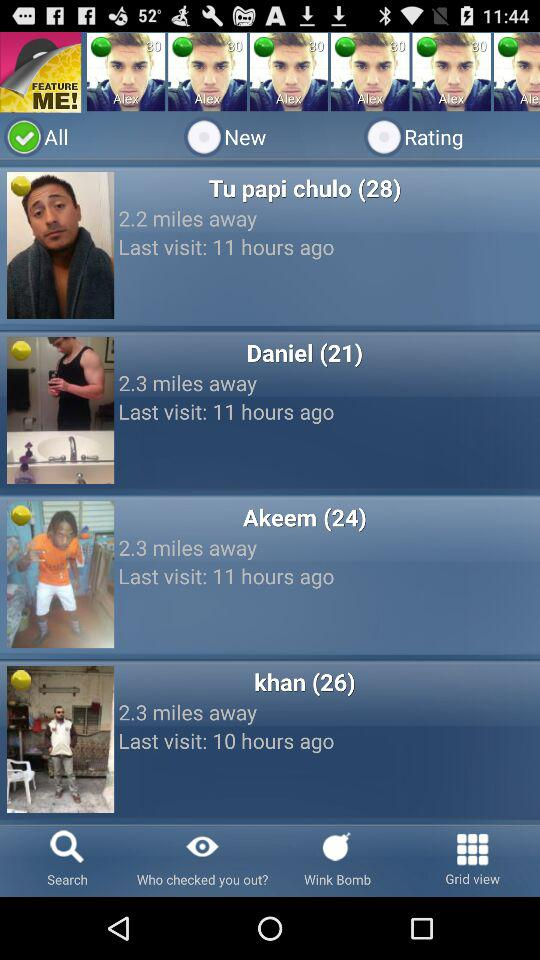When did khan last visit? The last visit by khan was 10 hours ago. 